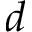Convert formula to latex. <formula><loc_0><loc_0><loc_500><loc_500>d</formula> 